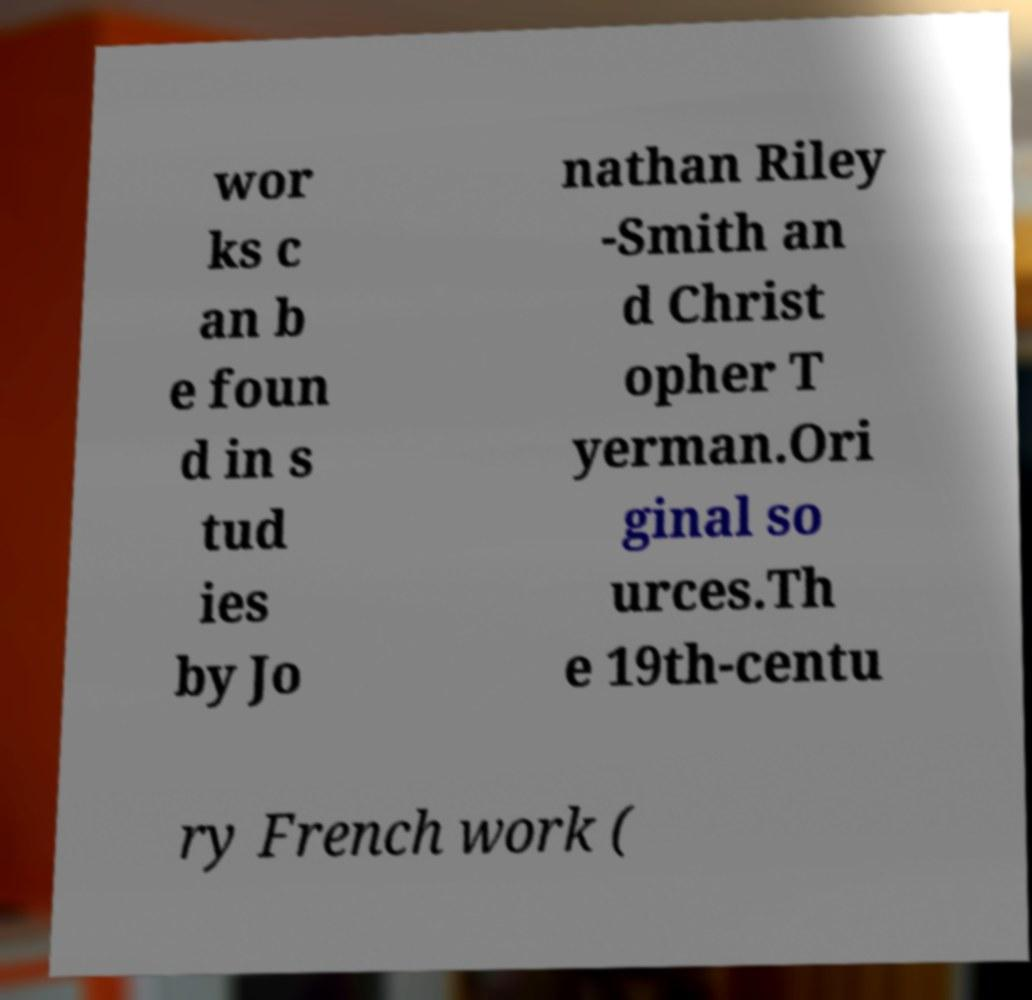For documentation purposes, I need the text within this image transcribed. Could you provide that? wor ks c an b e foun d in s tud ies by Jo nathan Riley -Smith an d Christ opher T yerman.Ori ginal so urces.Th e 19th-centu ry French work ( 